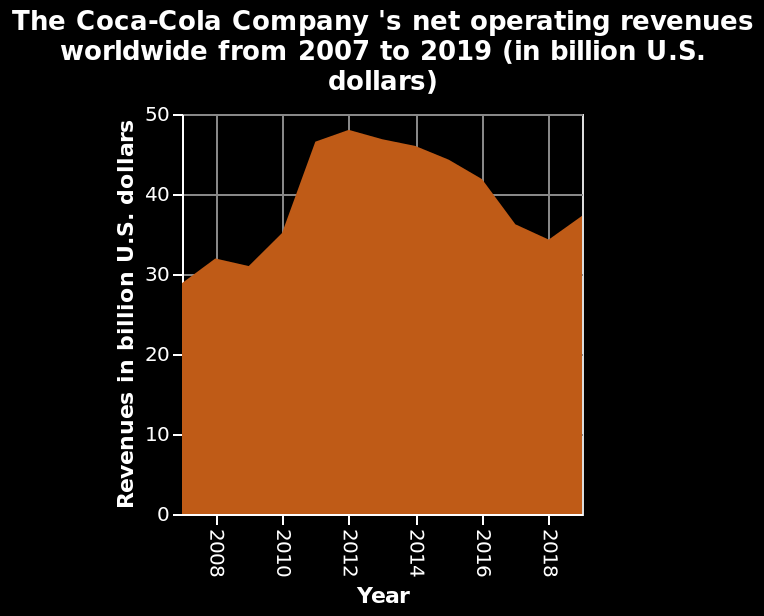<image>
How would you describe the trend after the biggest decrease?  The trend after the biggest decrease was an increase. 